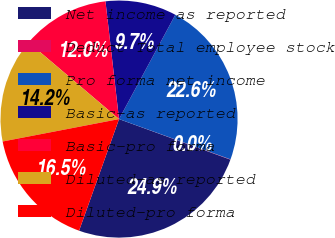<chart> <loc_0><loc_0><loc_500><loc_500><pie_chart><fcel>Net income as reported<fcel>Deduct Total employee stock<fcel>Pro forma net income<fcel>Basic-as reported<fcel>Basic-pro forma<fcel>Diluted-as reported<fcel>Diluted-pro forma<nl><fcel>24.91%<fcel>0.04%<fcel>22.64%<fcel>9.7%<fcel>11.97%<fcel>14.23%<fcel>16.5%<nl></chart> 